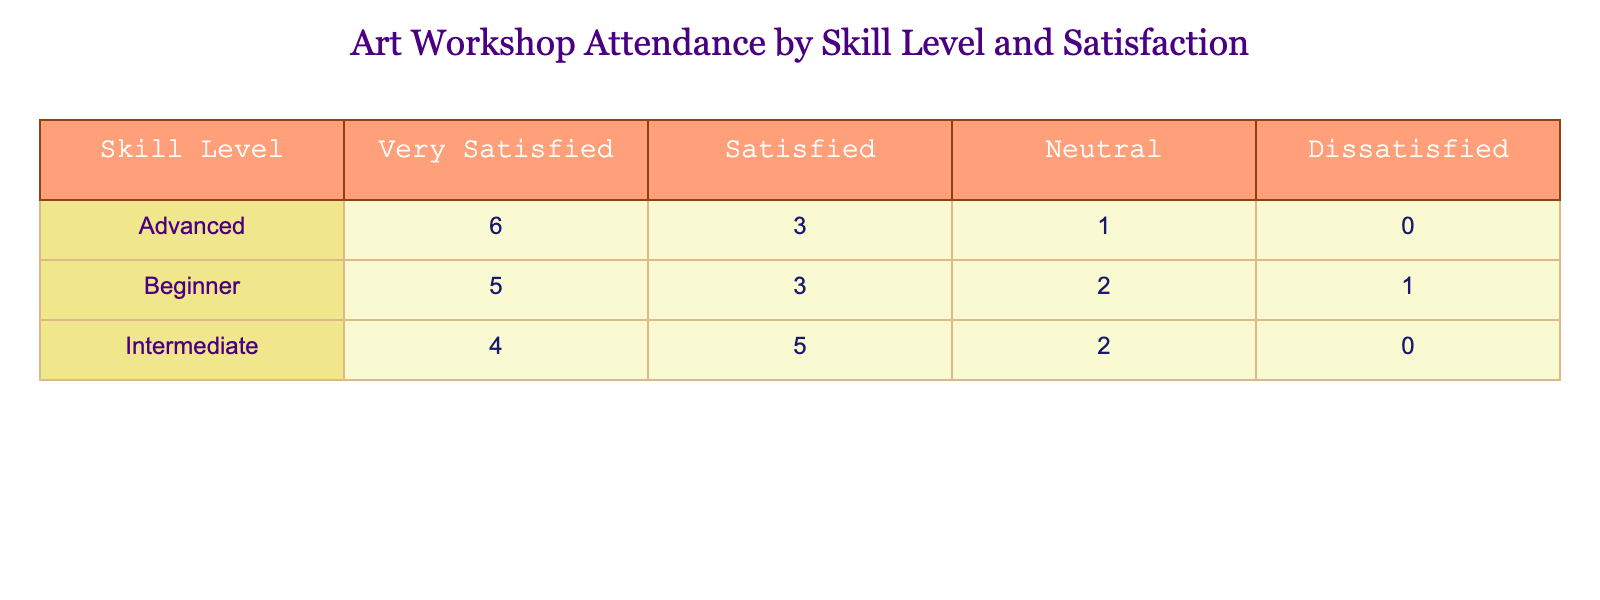What is the frequency of workshops attended by beginners who are very satisfied? The table shows that beginners who are very satisfied attended 5 workshops.
Answer: 5 How many intermediate participants felt dissatisfied with the workshops? The table indicates that the frequency of workshops attended by intermediate participants who felt dissatisfied is 0.
Answer: 0 What is the total number of workshops attended by advanced participants? Adding the frequencies from the advanced skill level (6 + 3 + 1 + 0) gives a total of 10 workshops attended by advanced participants.
Answer: 10 Which skill level has the highest number of participants who were very satisfied? The advanced skill level has the highest number of participants who were very satisfied, with a frequency of 6.
Answer: Advanced What is the average frequency of workshops attended by beginner participants? Calculating the average involves summing the frequencies (5 + 3 + 2 + 1 = 11) and dividing by the number of categories (4), which results in an average of 11/4 = 2.75.
Answer: 2.75 Is it true that no advanced participants reported feeling dissatisfied? Looking at the advanced skill level row, the frequency for dissatisfied participants is 0, confirming that no advanced participants reported feeling dissatisfied.
Answer: Yes How many total participants reported being satisfied regardless of their skill level? Summing the frequencies across all skill levels for "Satisfied" (3 + 5 + 3 = 11) gives a total of 11 satisfied participants.
Answer: 11 What is the difference in the number of workshops attended by very satisfied beginners and very satisfied intermediate participants? The very satisfied beginners attended 5 workshops while the very satisfied intermediate participants attended 4, so the difference is 5 - 4 = 1.
Answer: 1 What percentage of total workshops attended by beginners resulted in a neutral satisfaction rating? The total workshops attended by beginners is 11, and the neutral rating frequency is 2; thus, the percentage is (2/11) * 100 ≈ 18.18%.
Answer: 18.18% 